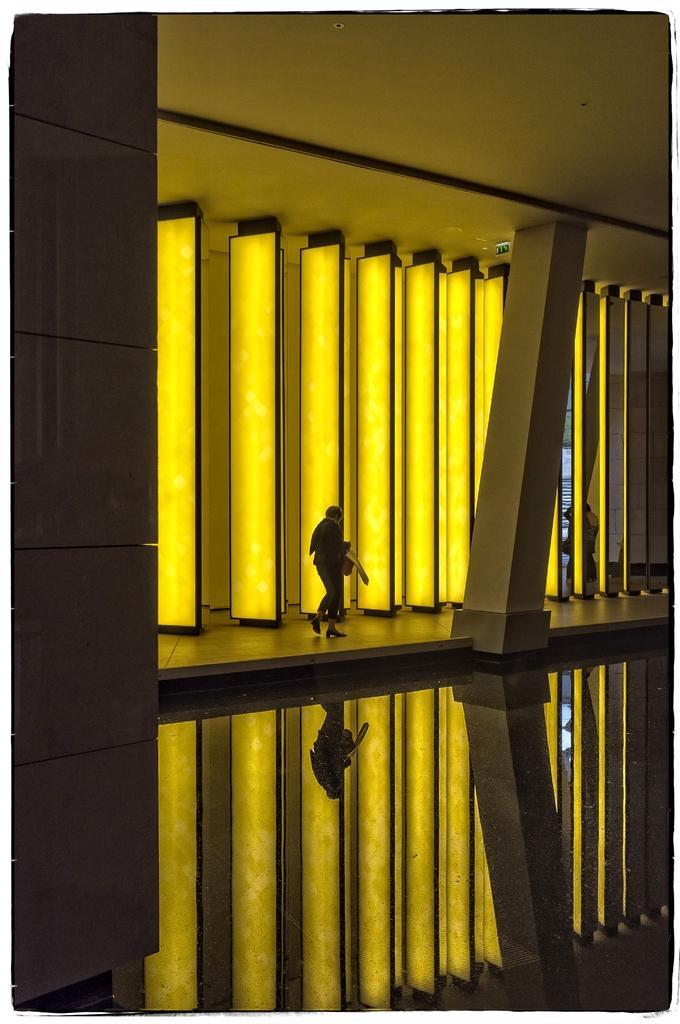Can you describe this image briefly? In this image we can see a person standing under a roof. In the background, we can see light poles. 